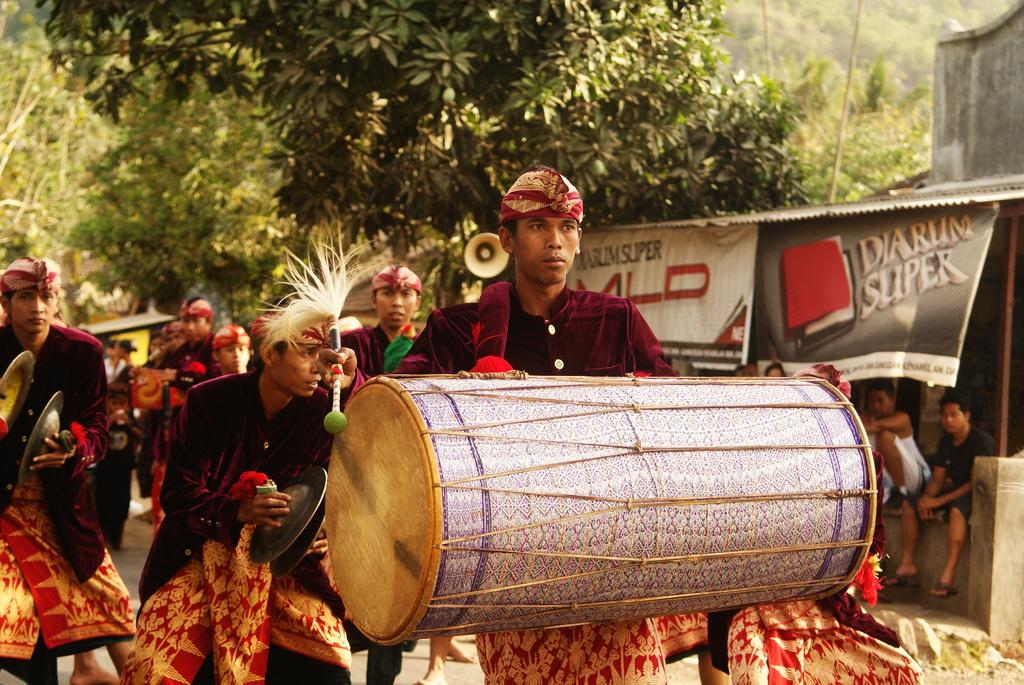What are the people in the image doing? There is a group of people performing musical instruments in the image. Can you describe the people on the right side of the image? There are two people sitting on the right side of the image. What is the banner in the image used for? The purpose of the banner in the image is not specified, but it could be for an event or to display information. What can be seen in the background of the image? In the background of the image, there is a shed, a tree, and a building. What type of attack is being carried out by the baseball team in the image? There is no baseball team or attack present in the image; it features a group of people performing musical instruments. How many people are attending the mass in the image? There is no mass or indication of a religious gathering in the image; it features a group of people performing musical instruments. 